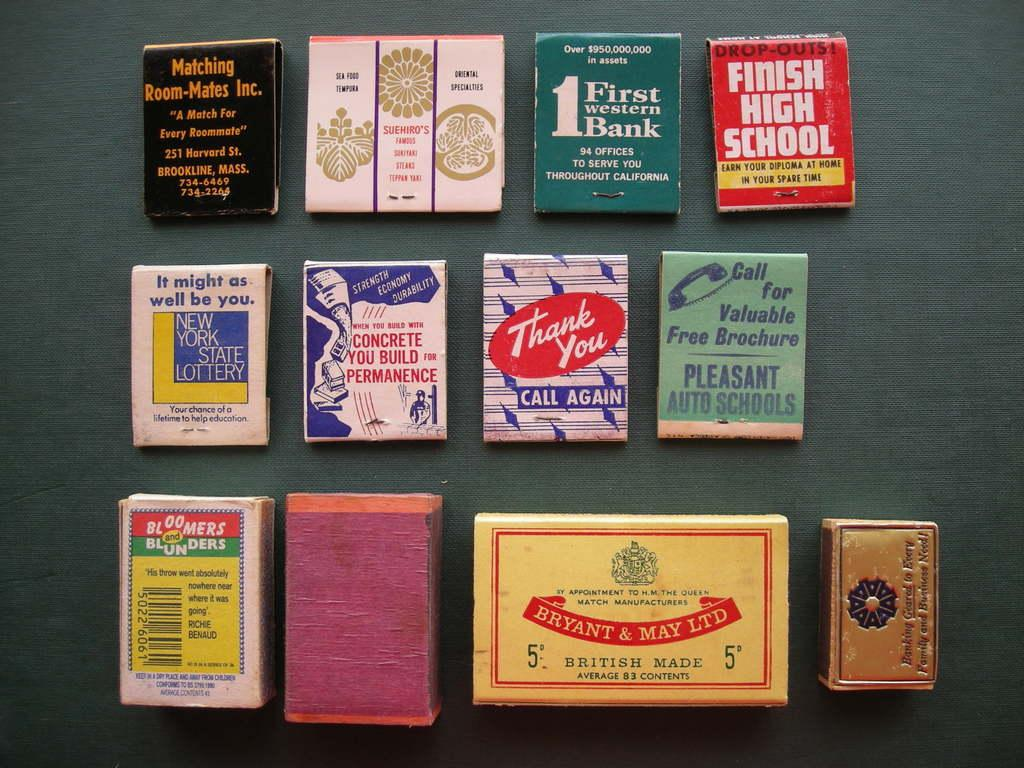<image>
Render a clear and concise summary of the photo. different objects on an area with one of them labeled 'bryant & may ltd' 